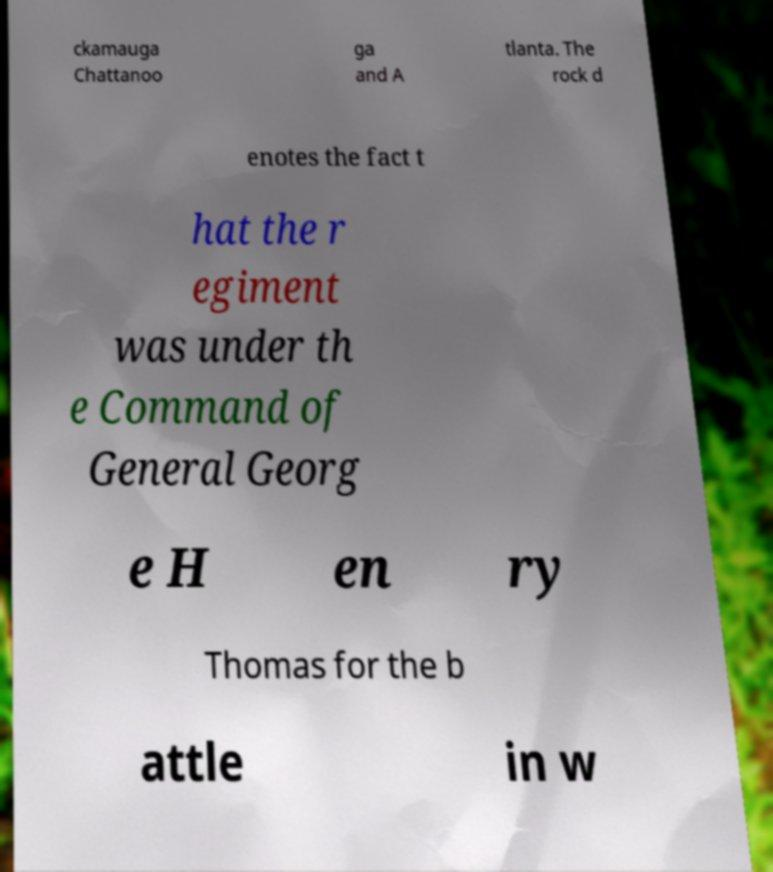Could you assist in decoding the text presented in this image and type it out clearly? ckamauga Chattanoo ga and A tlanta. The rock d enotes the fact t hat the r egiment was under th e Command of General Georg e H en ry Thomas for the b attle in w 